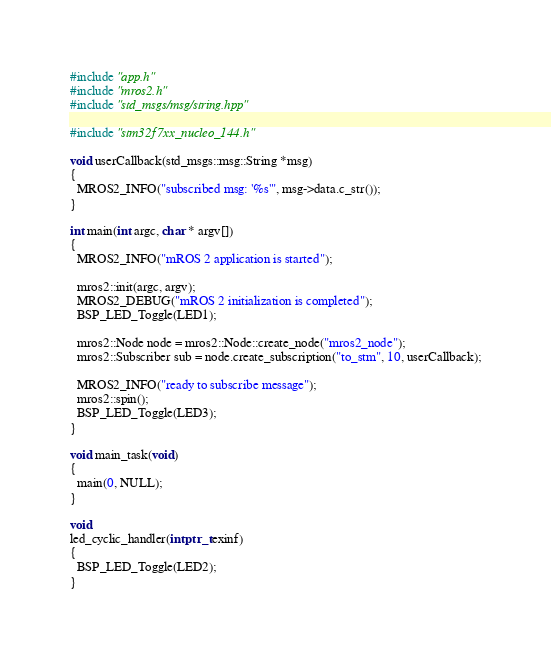<code> <loc_0><loc_0><loc_500><loc_500><_C++_>#include "app.h"
#include "mros2.h"
#include "std_msgs/msg/string.hpp"

#include "stm32f7xx_nucleo_144.h"

void userCallback(std_msgs::msg::String *msg)
{
  MROS2_INFO("subscribed msg: '%s'", msg->data.c_str());
}

int main(int argc, char * argv[])
{
  MROS2_INFO("mROS 2 application is started");

  mros2::init(argc, argv);
  MROS2_DEBUG("mROS 2 initialization is completed");
  BSP_LED_Toggle(LED1);

  mros2::Node node = mros2::Node::create_node("mros2_node");
  mros2::Subscriber sub = node.create_subscription("to_stm", 10, userCallback);

  MROS2_INFO("ready to subscribe message");
  mros2::spin();
  BSP_LED_Toggle(LED3);
}

void main_task(void)
{
  main(0, NULL);
}

void
led_cyclic_handler(intptr_t exinf)
{
  BSP_LED_Toggle(LED2);
}
</code> 